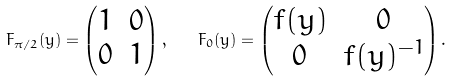Convert formula to latex. <formula><loc_0><loc_0><loc_500><loc_500>F _ { \pi / 2 } ( y ) = \begin{pmatrix} 1 & 0 \\ 0 & 1 \end{pmatrix} , \quad F _ { 0 } ( y ) = \begin{pmatrix} f ( y ) & 0 \\ 0 & f ( y ) ^ { - 1 } \end{pmatrix} .</formula> 